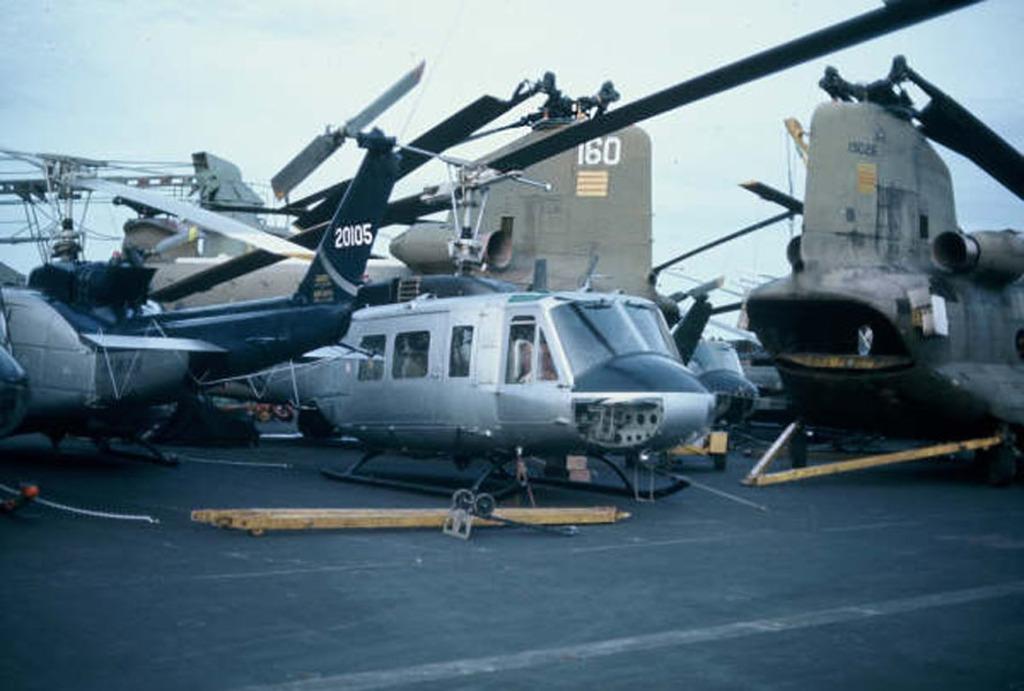What is the number on the tail fin of the helicopter on the left?
Provide a succinct answer. 20105. 